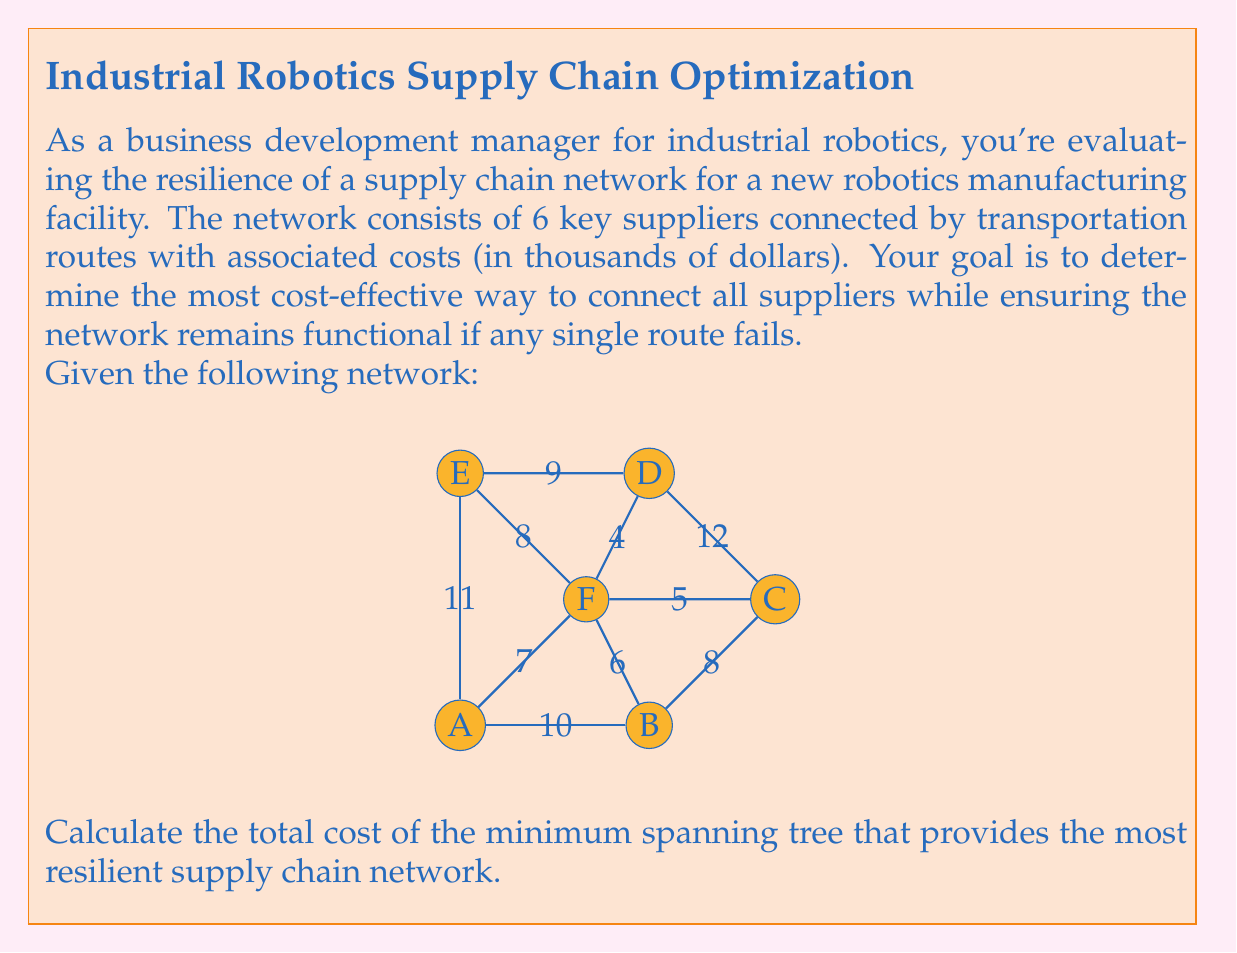Can you solve this math problem? To solve this problem, we'll use Kruskal's algorithm to find the minimum spanning tree (MST) of the given network. However, to ensure resilience, we need to consider the second-best option for each connection. This approach is known as the "2-edge-connected minimum spanning tree" or "2-ECMST".

Step 1: Sort all edges by weight (cost) in ascending order:
1. F-D: 4
2. C-F: 5
3. B-F: 6
4. A-F: 7
5. B-C: 8
6. E-F: 8
7. D-E: 9
8. A-B: 10
9. E-A: 11
10. C-D: 12

Step 2: Apply Kruskal's algorithm, but for each edge added, also add the next best edge that doesn't create a cycle:

1. Add F-D (4)
2. Add C-F (5) and B-F (6) (next best edge not creating a cycle)
3. Add A-F (7)
4. Add E-F (8) (D-E would create a cycle)

At this point, all nodes are connected with redundancy.

Step 3: Calculate the total cost:
Total cost = 4 + 5 + 6 + 7 + 8 = 30

This solution ensures that if any single edge fails, the network remains connected, providing resilience to the supply chain.
Answer: $30,000 